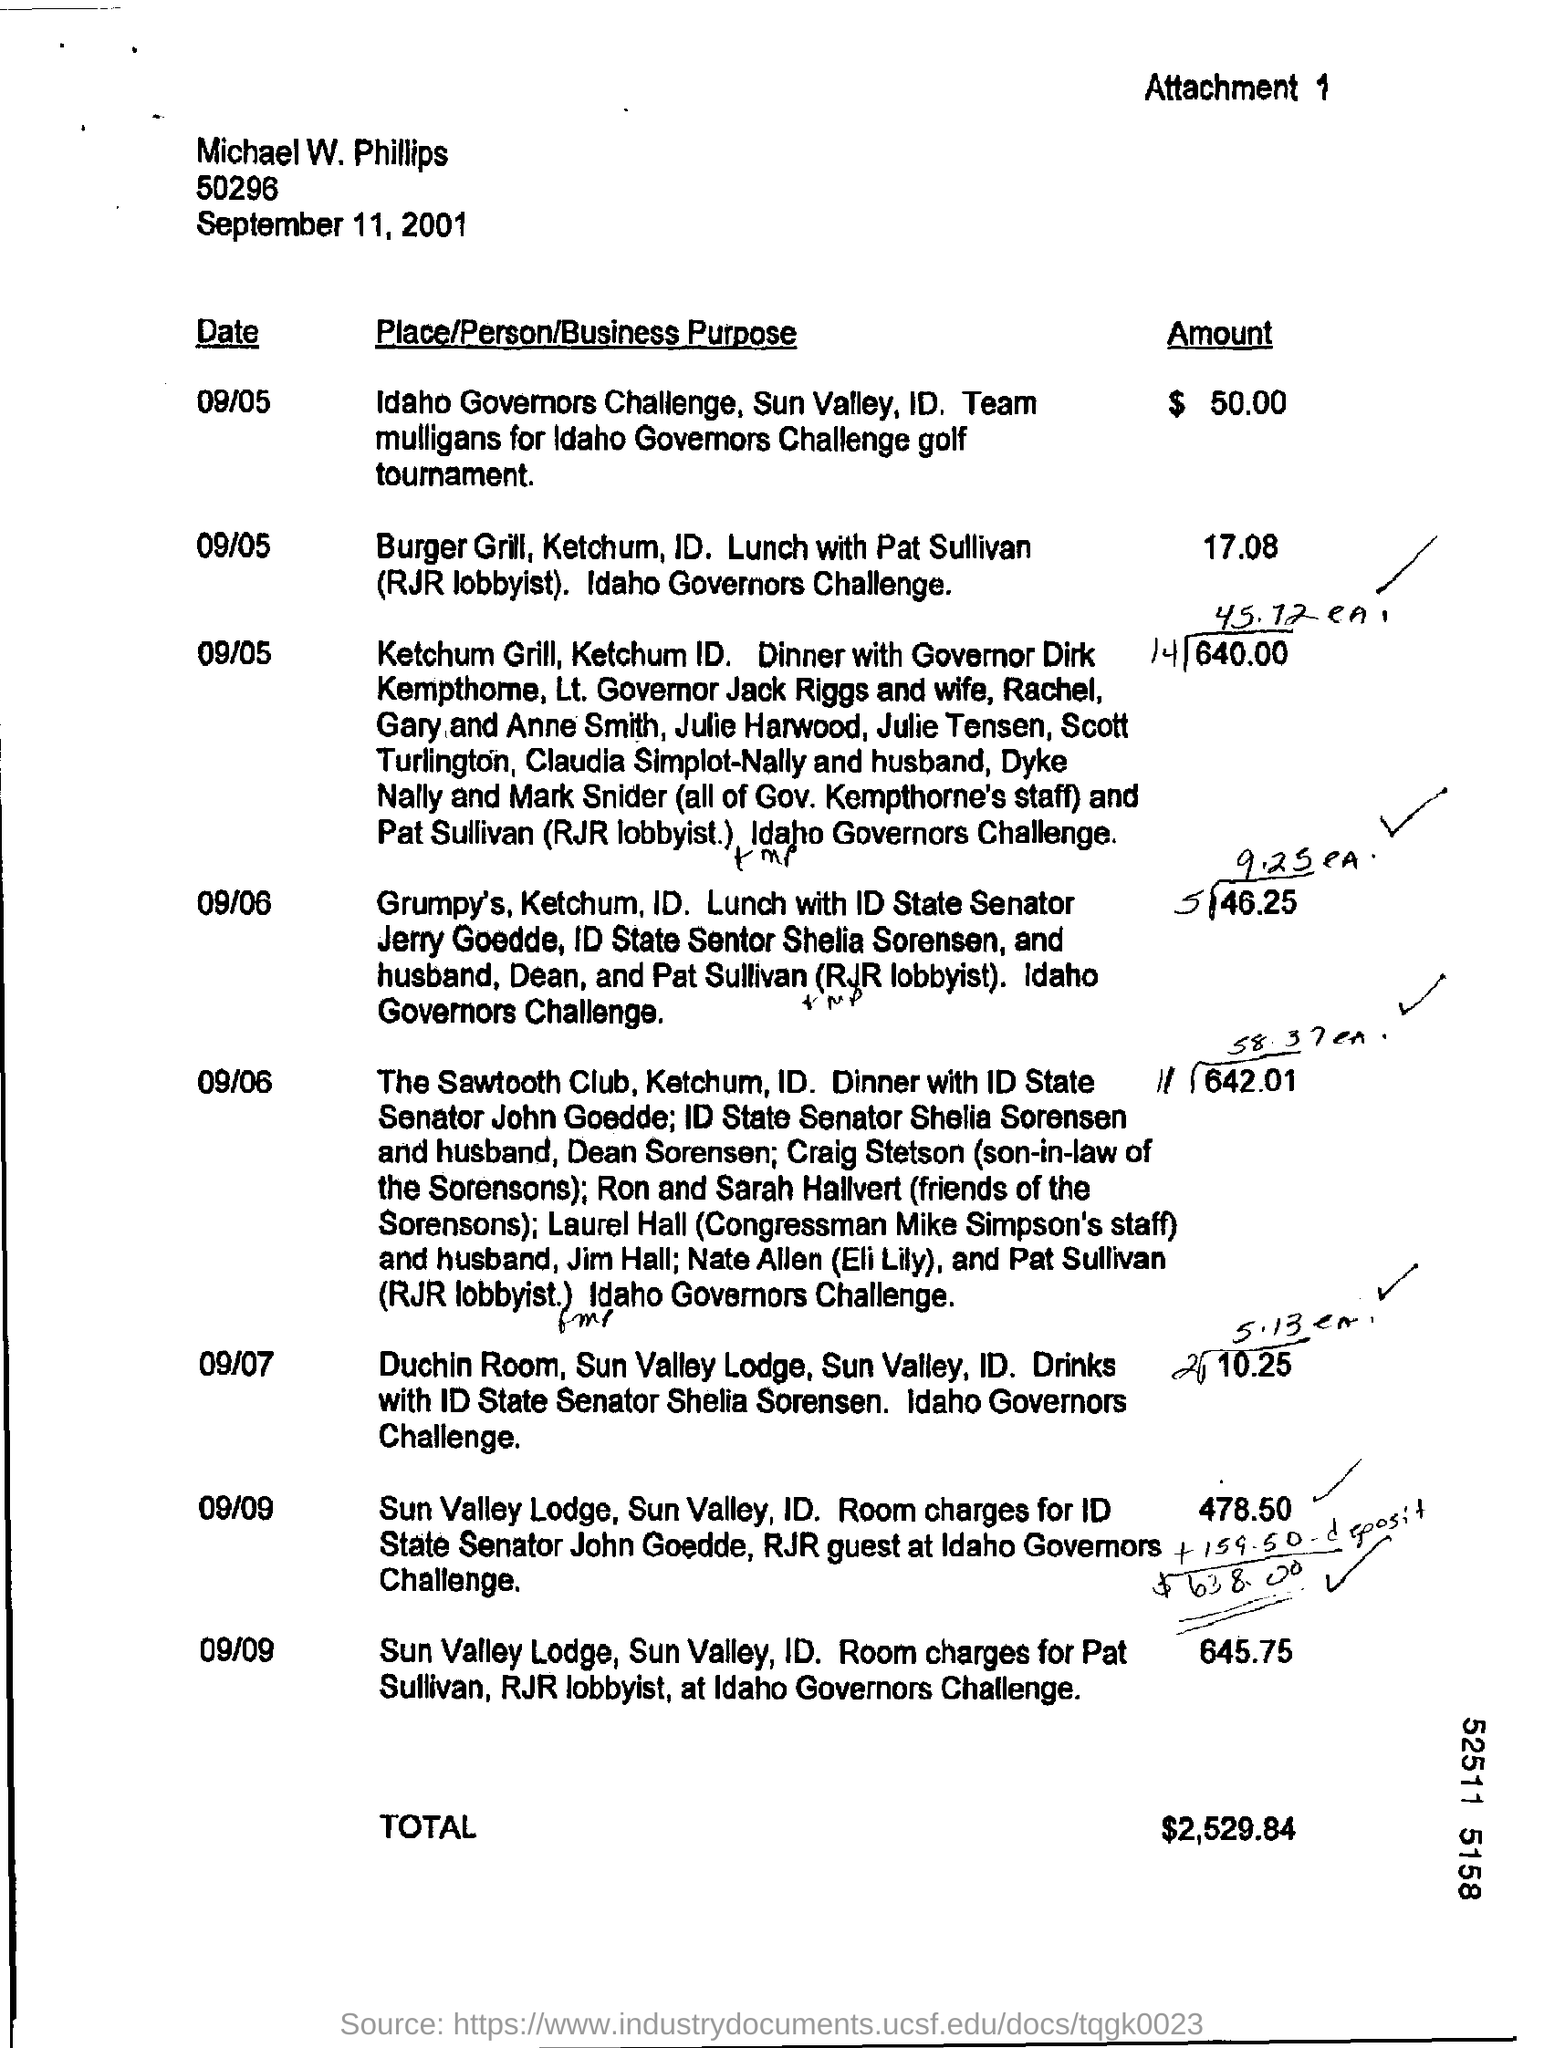What is the attachment number?
Your response must be concise. 1. What is the total amount for the day 9/7
Ensure brevity in your answer.  10.25. 